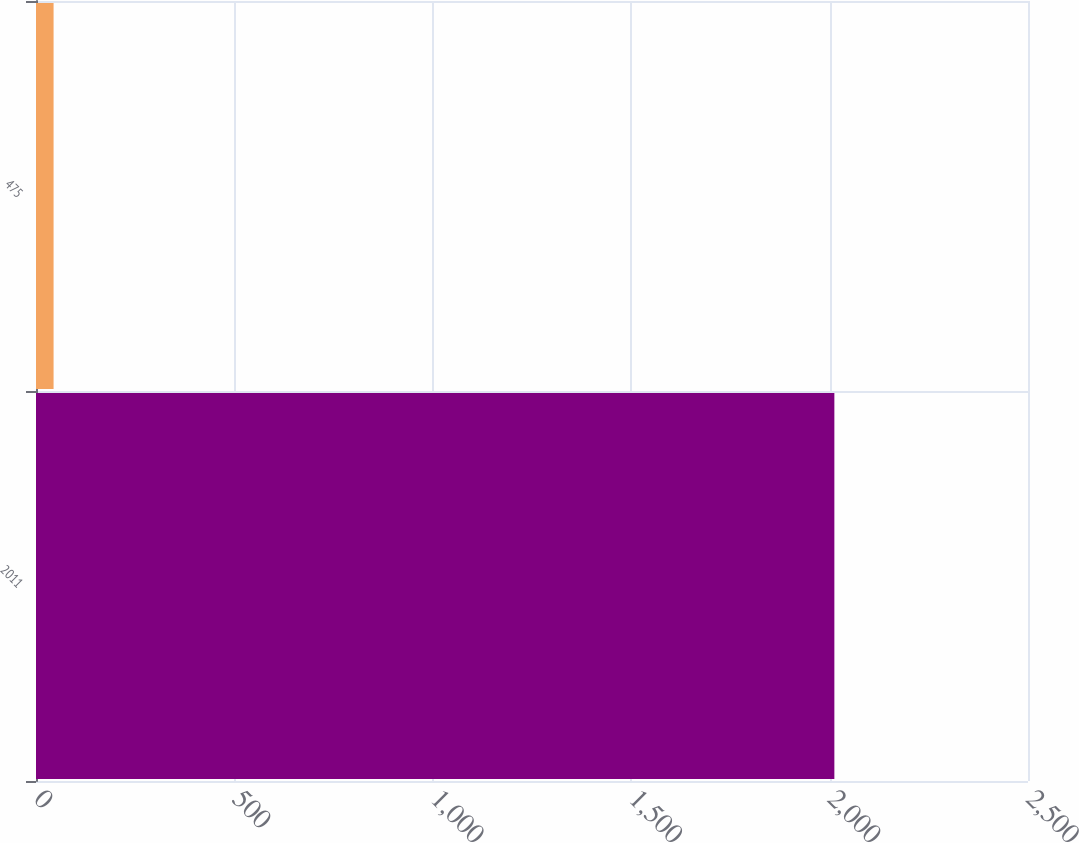<chart> <loc_0><loc_0><loc_500><loc_500><bar_chart><fcel>2011<fcel>475<nl><fcel>2012<fcel>44.3<nl></chart> 